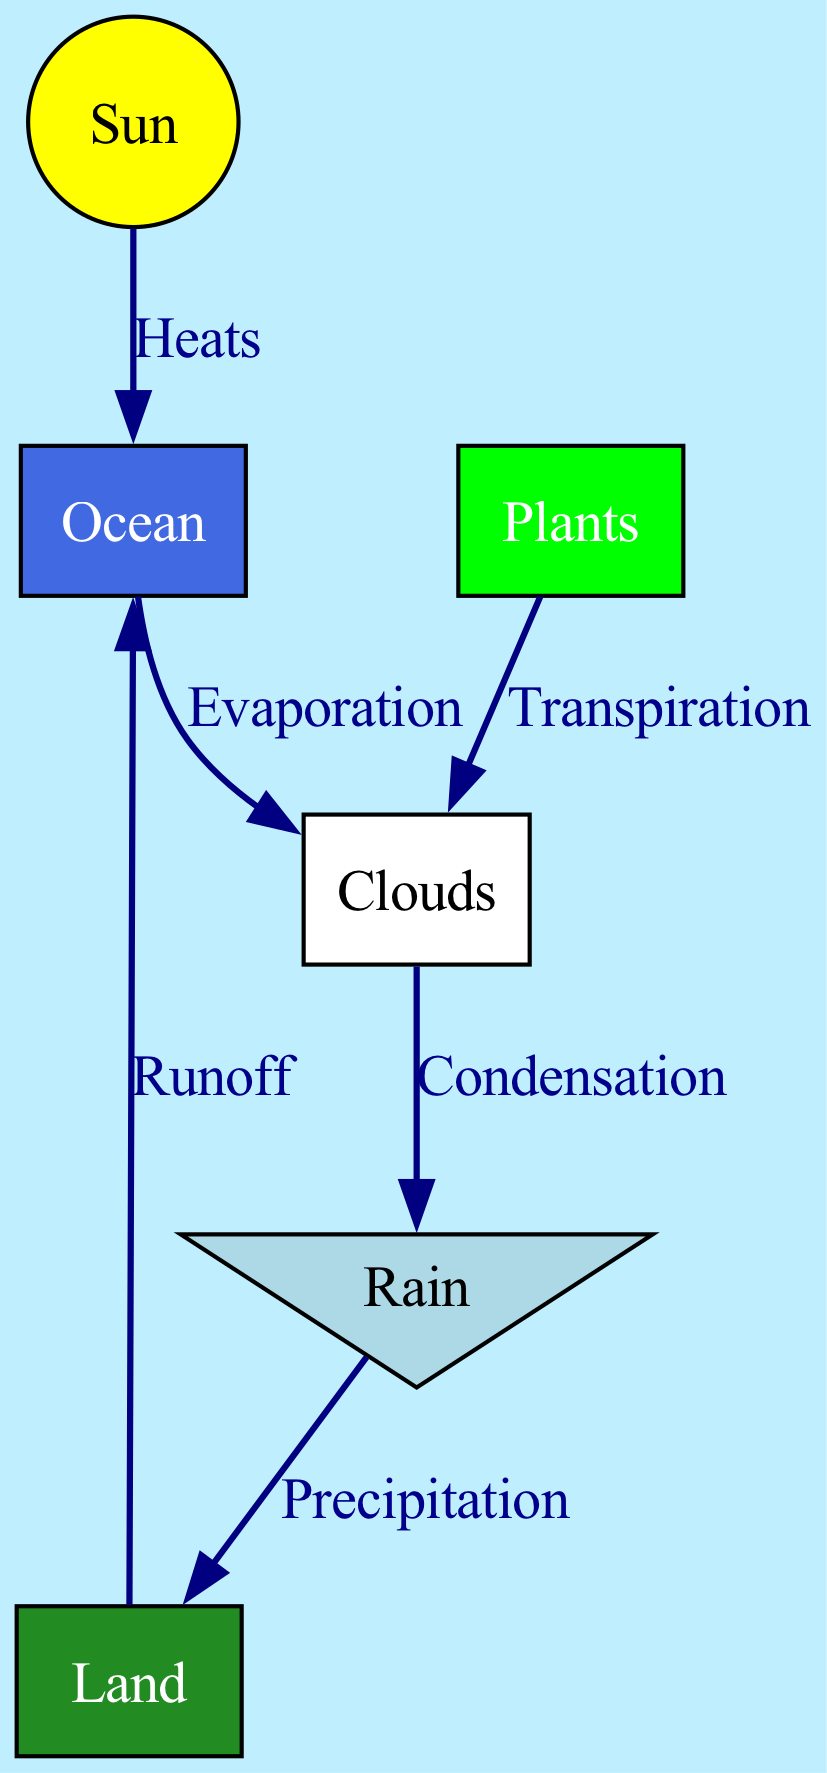What are the main components of the water cycle in the diagram? The diagram includes six main components: Sun, Ocean, Clouds, Rain, Land, and Plants. They are represented as different nodes.
Answer: Sun, Ocean, Clouds, Rain, Land, Plants What process is shown between the ocean and the clouds? The diagram indicates that the process between the ocean and the clouds is "Evaporation," which is labeled on the edge connecting these two nodes.
Answer: Evaporation How many edges are there in total in the diagram? By counting the connections (edges) in the diagram, there are six distinct edges showing relationships between nodes.
Answer: 6 What does the rain fall onto in the water cycle? According to the diagram, rain falls onto the land, as indicated by the edge labeled "Precipitation" connecting rain to land.
Answer: Land What process occurs after rain in the water cycle? Following "Precipitation," the process shown is "Runoff," indicating that water from the land flows back into the ocean. This information is conveyed by the edge between land and ocean.
Answer: Runoff Which component of the water cycle is responsible for adding moisture to the clouds apart from evaporation? The additional process of "Transpiration" from the plants adds moisture to the clouds as represented in the diagram.
Answer: Transpiration What is the color representing the ocean in the diagram? The ocean is depicted in royal blue according to the color specification in the nodes of the diagram.
Answer: Royal blue Which node does the sun directly heat? The diagram shows that the sun directly heats the ocean, as indicated by the labeled edge connecting the sun to the ocean.
Answer: Ocean How does water return to the clouds after falling as rain? Water returns to the clouds through the processes of "Evaporation" from the ocean and "Transpiration" from the plants, which adds moisture back into the atmosphere.
Answer: Evaporation, Transpiration 